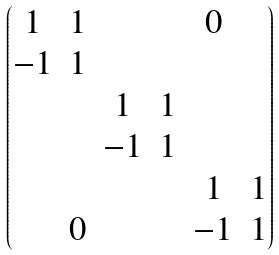<formula> <loc_0><loc_0><loc_500><loc_500>\begin{pmatrix} 1 & 1 & & & 0 & \\ - 1 & 1 & & & & \\ & & 1 & 1 & & \\ & & - 1 & 1 & & \\ & & & & 1 & 1 \\ & 0 & & & - 1 & 1 \\ \end{pmatrix}</formula> 